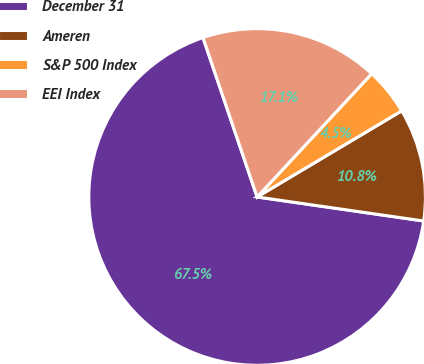Convert chart. <chart><loc_0><loc_0><loc_500><loc_500><pie_chart><fcel>December 31<fcel>Ameren<fcel>S&P 500 Index<fcel>EEI Index<nl><fcel>67.51%<fcel>10.83%<fcel>4.53%<fcel>17.13%<nl></chart> 